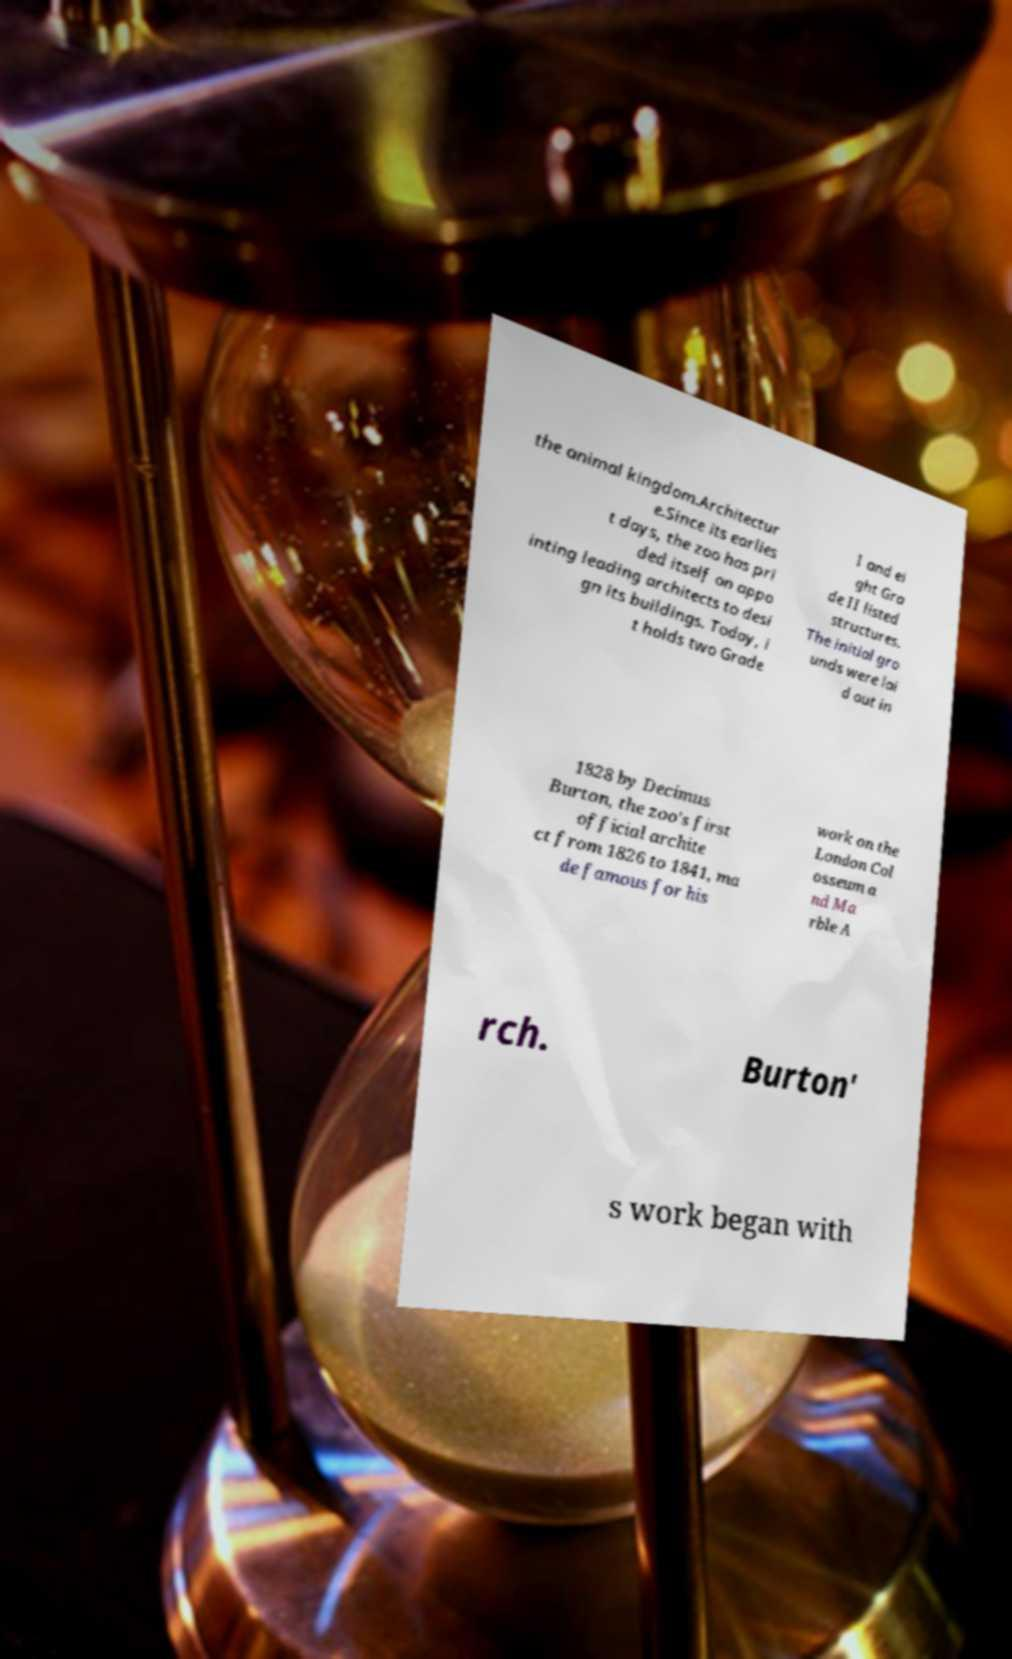For documentation purposes, I need the text within this image transcribed. Could you provide that? the animal kingdom.Architectur e.Since its earlies t days, the zoo has pri ded itself on appo inting leading architects to desi gn its buildings. Today, i t holds two Grade I and ei ght Gra de II listed structures. The initial gro unds were lai d out in 1828 by Decimus Burton, the zoo's first official archite ct from 1826 to 1841, ma de famous for his work on the London Col osseum a nd Ma rble A rch. Burton' s work began with 